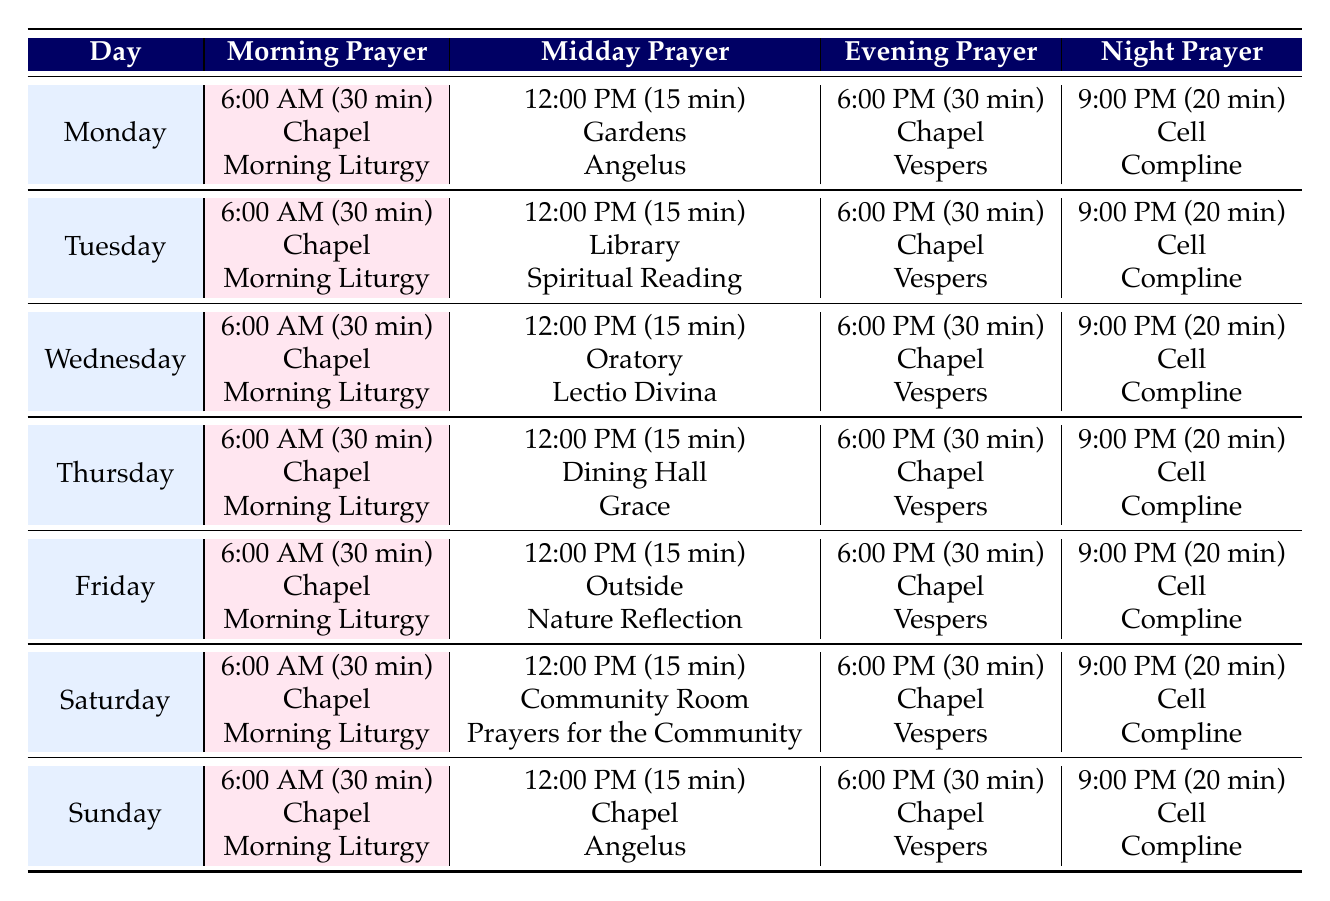What time is the morning prayer on Wednesday? The table shows that the morning prayer on Wednesday is at 6:00 AM.
Answer: 6:00 AM How long does evening prayer last on Friday? According to the table, the evening prayer on Friday lasts for 30 minutes.
Answer: 30 minutes Where is the midday prayer held on Thursday? The table indicates that the midday prayer on Thursday takes place in the Dining Hall.
Answer: Dining Hall Is the midday prayer on Saturday a part of the usual prayers? The midday prayer on Saturday is Prayers for the Community, which is specific to that day and reflects the community-centered nature of Saturday afternoons. Hence, it is a specific prayer for Saturday but part of the overall prayer structure.
Answer: Yes What is the total duration of prayers conducted on Tuesday? To find this, we sum the durations of all prayers: Morning (30) + Midday (15) + Evening (30) + Night (20) = 95 minutes total for Tuesday.
Answer: 95 minutes On which day is the Nature Reflection held? The table shows that the Nature Reflection occurs on Friday during the midday prayer.
Answer: Friday How many prayers last for 15 minutes during the week? Reviewing the table, the midday prayers on Monday, Tuesday, Wednesday, Thursday, Friday, Saturday, and Sunday reveal that only one specific prayer (the Midday prayer on each of these days) lasts for 15 minutes, which means there are 7 occurrences of the 15-minute prayers.
Answer: 7 Which prayer concludes the day on Sunday, and where is it held? On Sunday, the night prayer, known as Compline, is held in the Cell at 9:00 PM and lasts for 20 minutes.
Answer: Compline in the Cell Does the evening prayer take place at the same time every day? The table shows that the evening prayer is consistently held at 6:00 PM every day, thus confirming that it does take place at the same time.
Answer: Yes What is the prayer type at midday on Wednesday? The table indicates that the midday prayer on Wednesday is Lectio Divina.
Answer: Lectio Divina 